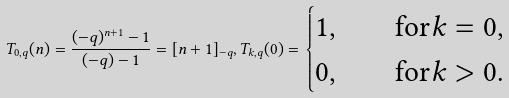<formula> <loc_0><loc_0><loc_500><loc_500>T _ { 0 , q } ( n ) = \frac { ( - q ) ^ { n + 1 } - 1 } { ( - q ) - 1 } = [ n + 1 ] _ { - q } , T _ { k , q } ( 0 ) = \begin{cases} 1 , & \quad \text {for} k = 0 , \\ 0 , & \quad \text {for} k > 0 . \end{cases}</formula> 